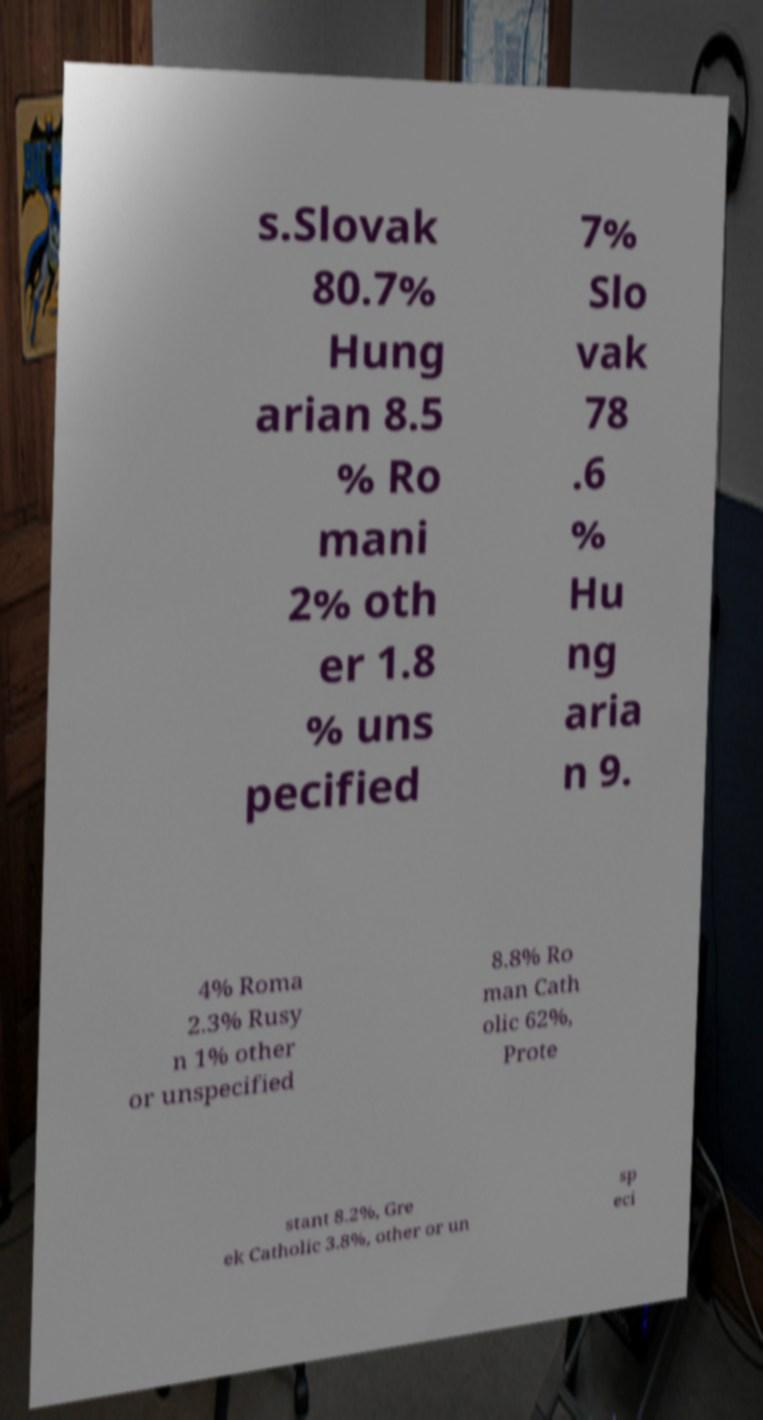There's text embedded in this image that I need extracted. Can you transcribe it verbatim? s.Slovak 80.7% Hung arian 8.5 % Ro mani 2% oth er 1.8 % uns pecified 7% Slo vak 78 .6 % Hu ng aria n 9. 4% Roma 2.3% Rusy n 1% other or unspecified 8.8% Ro man Cath olic 62%, Prote stant 8.2%, Gre ek Catholic 3.8%, other or un sp eci 